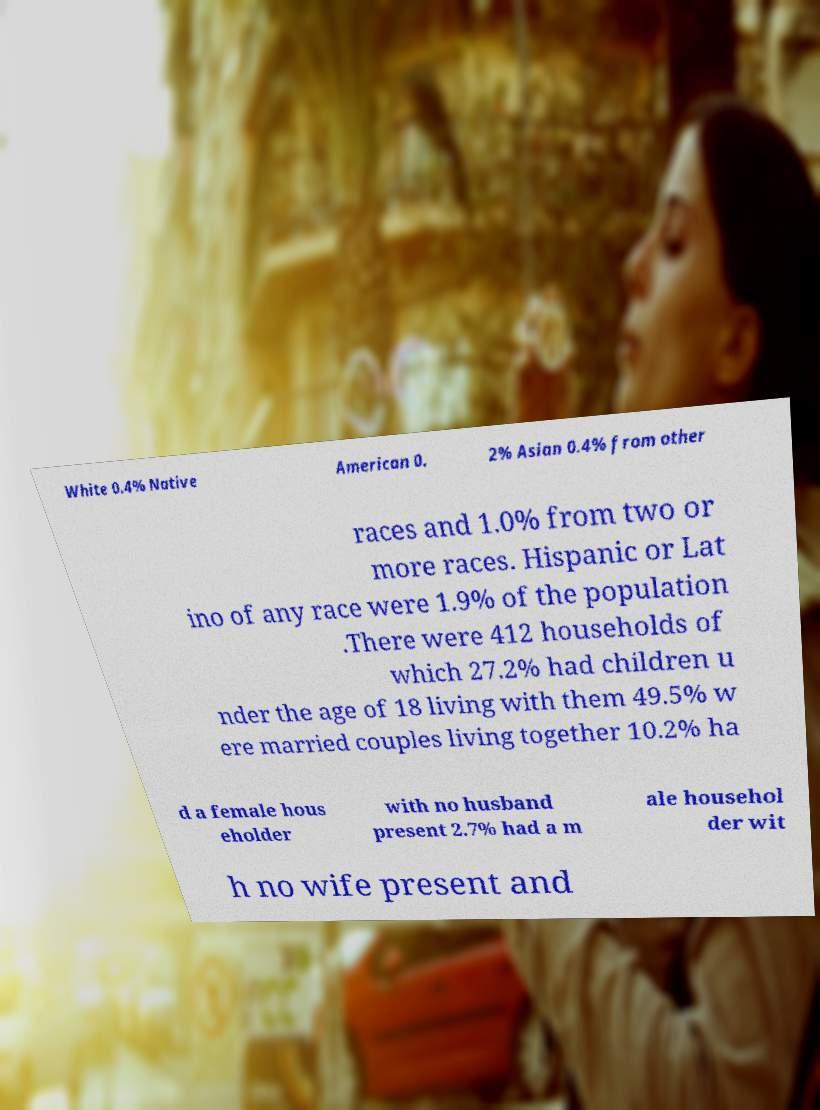Please identify and transcribe the text found in this image. White 0.4% Native American 0. 2% Asian 0.4% from other races and 1.0% from two or more races. Hispanic or Lat ino of any race were 1.9% of the population .There were 412 households of which 27.2% had children u nder the age of 18 living with them 49.5% w ere married couples living together 10.2% ha d a female hous eholder with no husband present 2.7% had a m ale househol der wit h no wife present and 